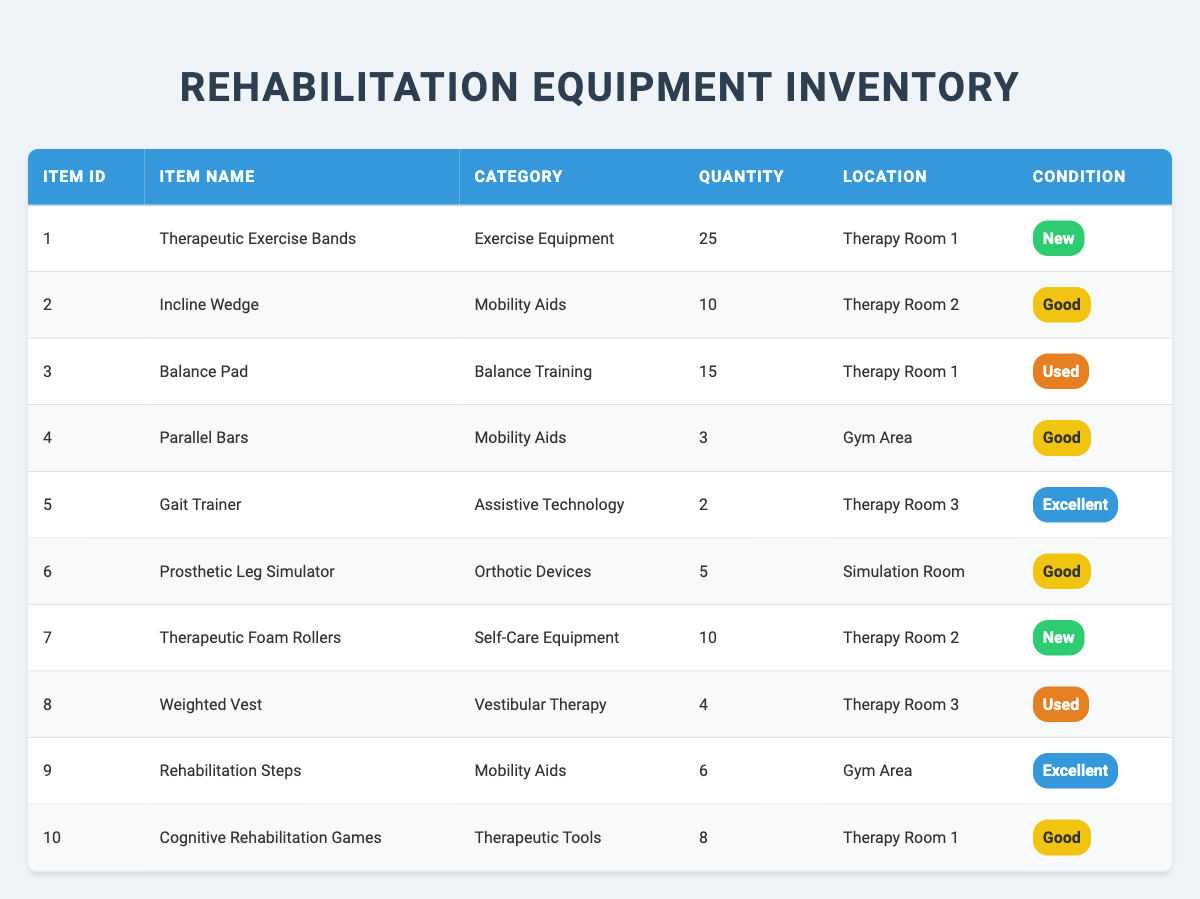What is the total quantity of Therapeutic Exercise Bands available? There is a single entry for Therapeutic Exercise Bands in the table with a quantity of 25. Therefore, the total quantity is simply 25.
Answer: 25 In which location are the Incline Wedges stored? From the table, it is clear that Incline Wedges are stored in Therapy Room 2.
Answer: Therapy Room 2 How many pieces of equipment are categorized under Mobility Aids? The table shows three entries under the category Mobility Aids: Incline Wedge, Parallel Bars, and Rehabilitation Steps. Adding these up gives a total of 3 pieces of equipment in this category.
Answer: 3 What is the condition of the Gait Trainer? The table indicates that the Gait Trainer has a condition listed as Excellent.
Answer: Excellent Which room has the highest quantity of rehabilitation equipment? Looking at the quantities listed in the table: Therapy Room 1 has 25 (Therapeutic Exercise Bands) + 15 (Balance Pad) + 8 (Cognitive Rehabilitation Games) = 48. Therapy Room 2 has 10 (Incline Wedge) + 10 (Therapeutic Foam Rollers) = 20. Therapy Room 3 has 2 (Gait Trainer) + 4 (Weighted Vest) = 6. Therefore, Therapy Room 1 has the highest quantity, which is 48.
Answer: Therapy Room 1 How many pieces of equipment are in 'Used' condition? Scanning through the table, the Balance Pad and Weighted Vest are the only pieces marked as Used. That totals to 2 pieces of equipment in Used condition.
Answer: 2 Is there any equipment stored in the Simulation Room? The table shows that the Prosthetic Leg Simulator is stored in the Simulation Room, confirming that there is indeed equipment in that location.
Answer: Yes What is the average quantity of equipment per category? There are 10 total items with the following quantities by category: Exercise Equipment (25), Mobility Aids (10 + 3 + 6 = 19), Balance Training (15), Assistive Technology (2), Orthotic Devices (5), Self-Care Equipment (10), Vestibular Therapy (4), and Therapeutic Tools (8). Summing these gives 25 + 19 + 15 + 2 + 5 + 10 + 4 + 8 = 88 total, and there are 8 categories. Therefore, the average is 88 / 8 = 11.
Answer: 11 How many pieces of equipment located in Therapy Room 3 are in 'Excellent' condition? In Therapy Room 3, there are two pieces of equipment: Gait Trainer and Weighted Vest. The Gait Trainer is in Excellent condition, while the Weighted Vest is marked as Used. Hence, only one piece in Therapy Room 3 is in Excellent condition.
Answer: 1 